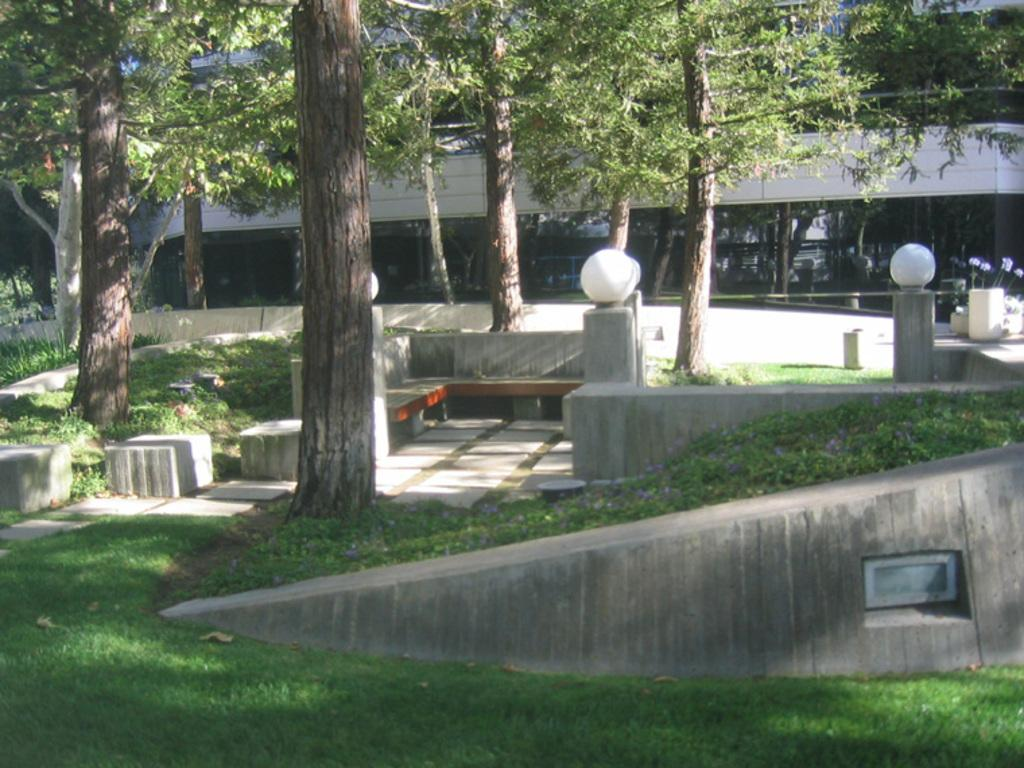What type of structure is present in the image? There is a building in the image. What can be seen in the background of the image? There are trees in the image. What is illuminating the scene in the image? Lights are visible in the image. What type of ground cover is present in the image? There is grass on the ground in the image. What type of vegetation is present in the image besides trees? There are plants in the image. Where is the mitten located in the image? There is no mitten present in the image. What type of road can be seen in the image? There is no road visible in the image. 